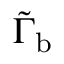Convert formula to latex. <formula><loc_0><loc_0><loc_500><loc_500>\tilde { \Gamma } _ { b }</formula> 